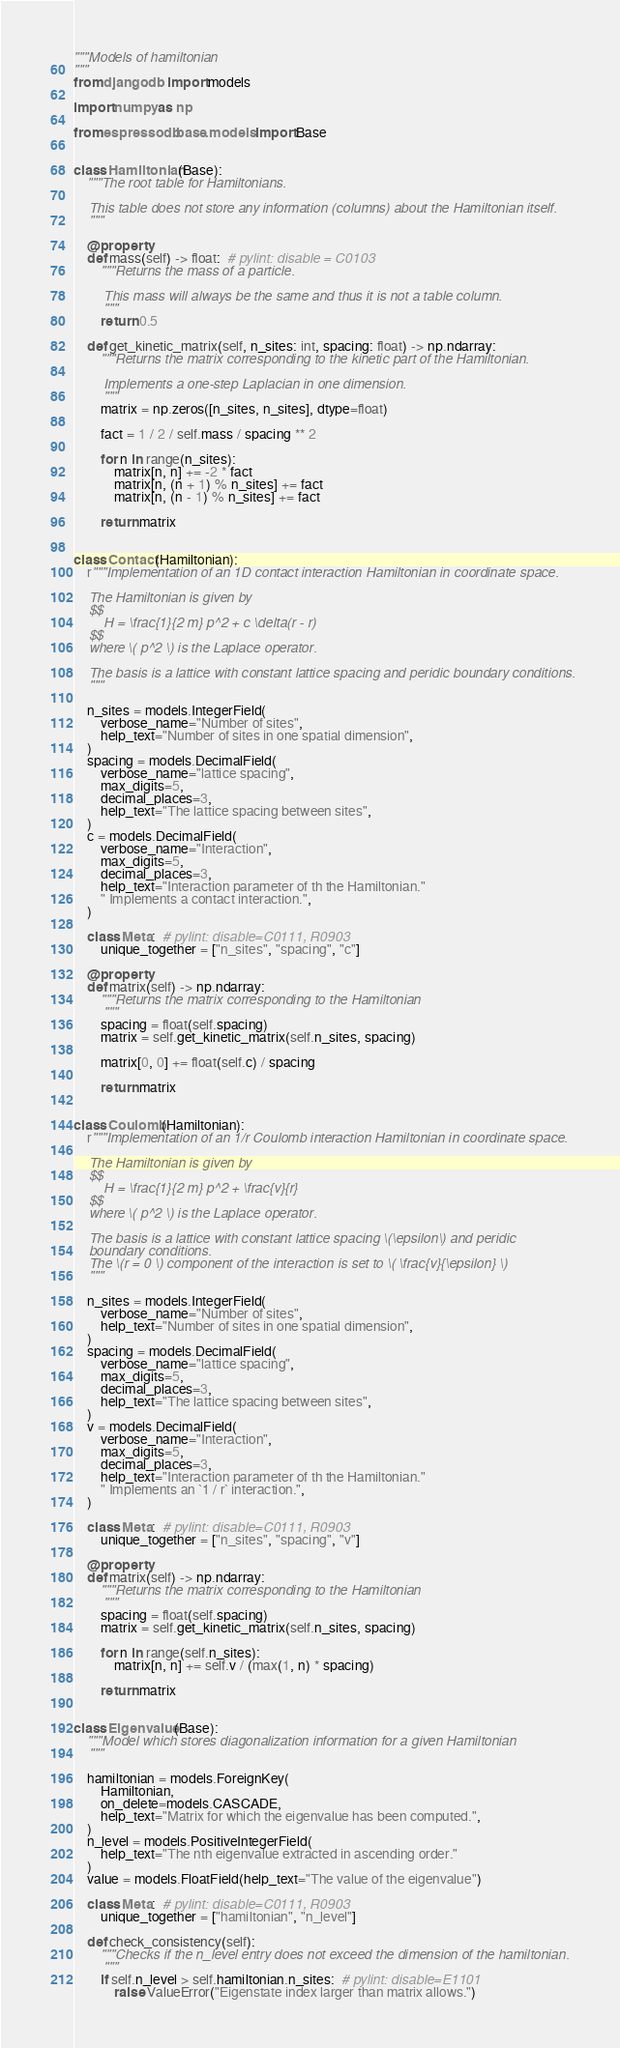Convert code to text. <code><loc_0><loc_0><loc_500><loc_500><_Python_>"""Models of hamiltonian
"""
from django.db import models

import numpy as np

from espressodb.base.models import Base


class Hamiltonian(Base):
    """The root table for Hamiltonians.

    This table does not store any information (columns) about the Hamiltonian itself.
    """

    @property
    def mass(self) -> float:  # pylint: disable = C0103
        """Returns the mass of a particle.

        This mass will always be the same and thus it is not a table column.
        """
        return 0.5

    def get_kinetic_matrix(self, n_sites: int, spacing: float) -> np.ndarray:
        """Returns the matrix corresponding to the kinetic part of the Hamiltonian.

        Implements a one-step Laplacian in one dimension.
        """
        matrix = np.zeros([n_sites, n_sites], dtype=float)

        fact = 1 / 2 / self.mass / spacing ** 2

        for n in range(n_sites):
            matrix[n, n] += -2 * fact
            matrix[n, (n + 1) % n_sites] += fact
            matrix[n, (n - 1) % n_sites] += fact

        return matrix


class Contact(Hamiltonian):
    r"""Implementation of an 1D contact interaction Hamiltonian in coordinate space.

    The Hamiltonian is given by
    $$
        H = \frac{1}{2 m} p^2 + c \delta(r - r)
    $$
    where \( p^2 \) is the Laplace operator.

    The basis is a lattice with constant lattice spacing and peridic boundary conditions.
    """

    n_sites = models.IntegerField(
        verbose_name="Number of sites",
        help_text="Number of sites in one spatial dimension",
    )
    spacing = models.DecimalField(
        verbose_name="lattice spacing",
        max_digits=5,
        decimal_places=3,
        help_text="The lattice spacing between sites",
    )
    c = models.DecimalField(
        verbose_name="Interaction",
        max_digits=5,
        decimal_places=3,
        help_text="Interaction parameter of th the Hamiltonian."
        " Implements a contact interaction.",
    )

    class Meta:  # pylint: disable=C0111, R0903
        unique_together = ["n_sites", "spacing", "c"]

    @property
    def matrix(self) -> np.ndarray:
        """Returns the matrix corresponding to the Hamiltonian
        """
        spacing = float(self.spacing)
        matrix = self.get_kinetic_matrix(self.n_sites, spacing)

        matrix[0, 0] += float(self.c) / spacing

        return matrix


class Coulomb(Hamiltonian):
    r"""Implementation of an 1/r Coulomb interaction Hamiltonian in coordinate space.

    The Hamiltonian is given by
    $$
        H = \frac{1}{2 m} p^2 + \frac{v}{r}
    $$
    where \( p^2 \) is the Laplace operator.

    The basis is a lattice with constant lattice spacing \(\epsilon\) and peridic
    boundary conditions.
    The \(r = 0 \) component of the interaction is set to \( \frac{v}{\epsilon} \)
    """

    n_sites = models.IntegerField(
        verbose_name="Number of sites",
        help_text="Number of sites in one spatial dimension",
    )
    spacing = models.DecimalField(
        verbose_name="lattice spacing",
        max_digits=5,
        decimal_places=3,
        help_text="The lattice spacing between sites",
    )
    v = models.DecimalField(
        verbose_name="Interaction",
        max_digits=5,
        decimal_places=3,
        help_text="Interaction parameter of th the Hamiltonian."
        " Implements an `1 / r` interaction.",
    )

    class Meta:  # pylint: disable=C0111, R0903
        unique_together = ["n_sites", "spacing", "v"]

    @property
    def matrix(self) -> np.ndarray:
        """Returns the matrix corresponding to the Hamiltonian
        """
        spacing = float(self.spacing)
        matrix = self.get_kinetic_matrix(self.n_sites, spacing)

        for n in range(self.n_sites):
            matrix[n, n] += self.v / (max(1, n) * spacing)

        return matrix


class Eigenvalue(Base):
    """Model which stores diagonalization information for a given Hamiltonian
    """

    hamiltonian = models.ForeignKey(
        Hamiltonian,
        on_delete=models.CASCADE,
        help_text="Matrix for which the eigenvalue has been computed.",
    )
    n_level = models.PositiveIntegerField(
        help_text="The nth eigenvalue extracted in ascending order."
    )
    value = models.FloatField(help_text="The value of the eigenvalue")

    class Meta:  # pylint: disable=C0111, R0903
        unique_together = ["hamiltonian", "n_level"]

    def check_consistency(self):
        """Checks if the n_level entry does not exceed the dimension of the hamiltonian.
        """
        if self.n_level > self.hamiltonian.n_sites:  # pylint: disable=E1101
            raise ValueError("Eigenstate index larger than matrix allows.")
</code> 